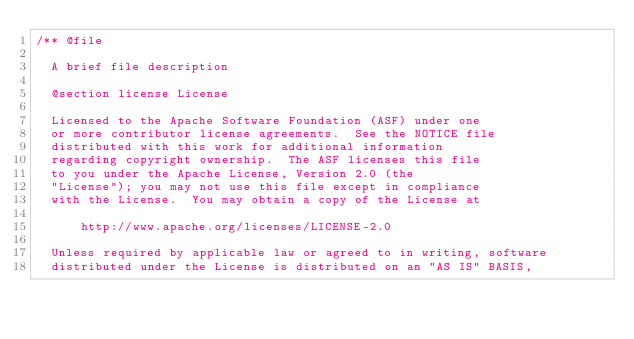<code> <loc_0><loc_0><loc_500><loc_500><_C++_>/** @file

  A brief file description

  @section license License

  Licensed to the Apache Software Foundation (ASF) under one
  or more contributor license agreements.  See the NOTICE file
  distributed with this work for additional information
  regarding copyright ownership.  The ASF licenses this file
  to you under the Apache License, Version 2.0 (the
  "License"); you may not use this file except in compliance
  with the License.  You may obtain a copy of the License at

      http://www.apache.org/licenses/LICENSE-2.0

  Unless required by applicable law or agreed to in writing, software
  distributed under the License is distributed on an "AS IS" BASIS,</code> 